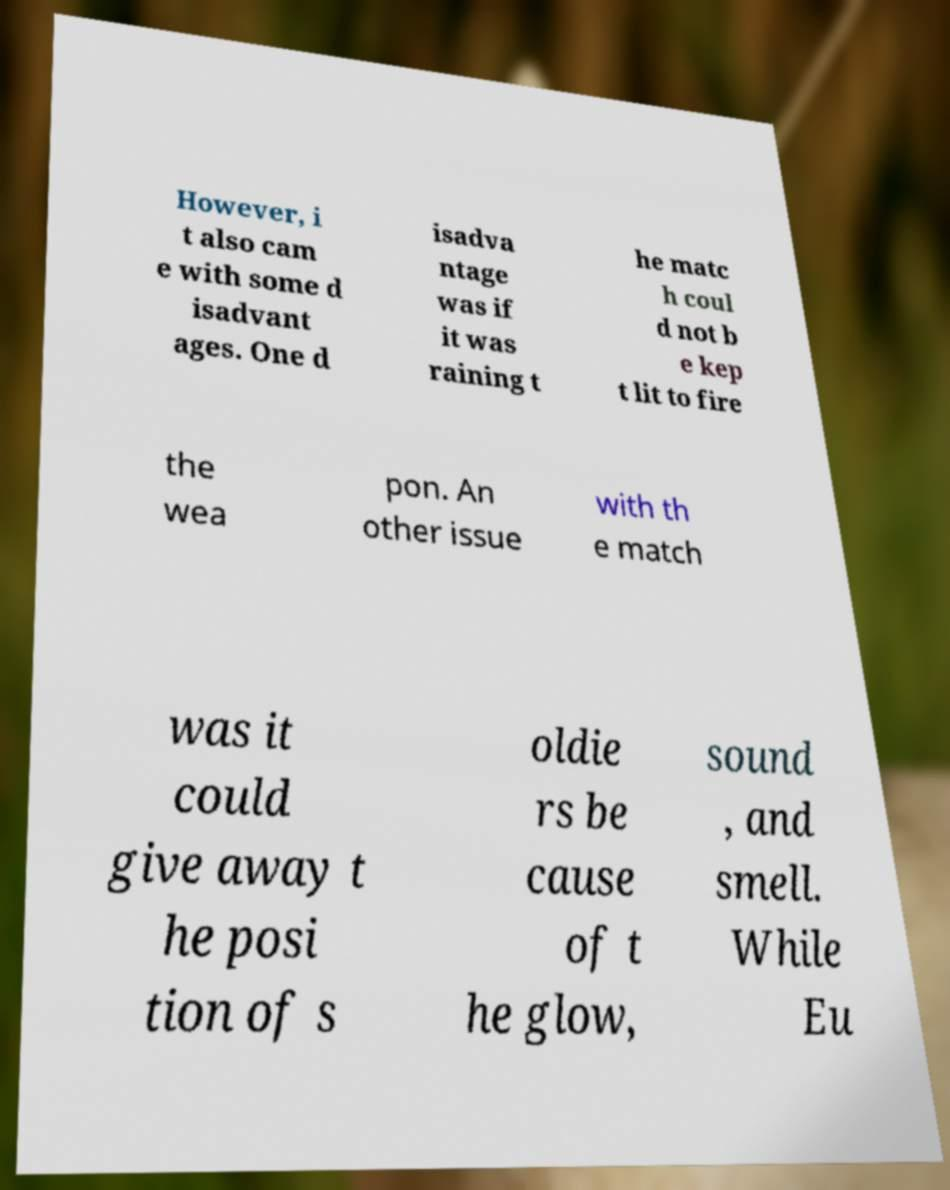Can you read and provide the text displayed in the image?This photo seems to have some interesting text. Can you extract and type it out for me? However, i t also cam e with some d isadvant ages. One d isadva ntage was if it was raining t he matc h coul d not b e kep t lit to fire the wea pon. An other issue with th e match was it could give away t he posi tion of s oldie rs be cause of t he glow, sound , and smell. While Eu 